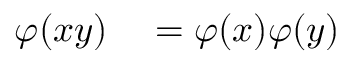<formula> <loc_0><loc_0><loc_500><loc_500>\begin{array} { r l } { \varphi ( x y ) } & = \varphi ( x ) \varphi ( y ) } \end{array}</formula> 